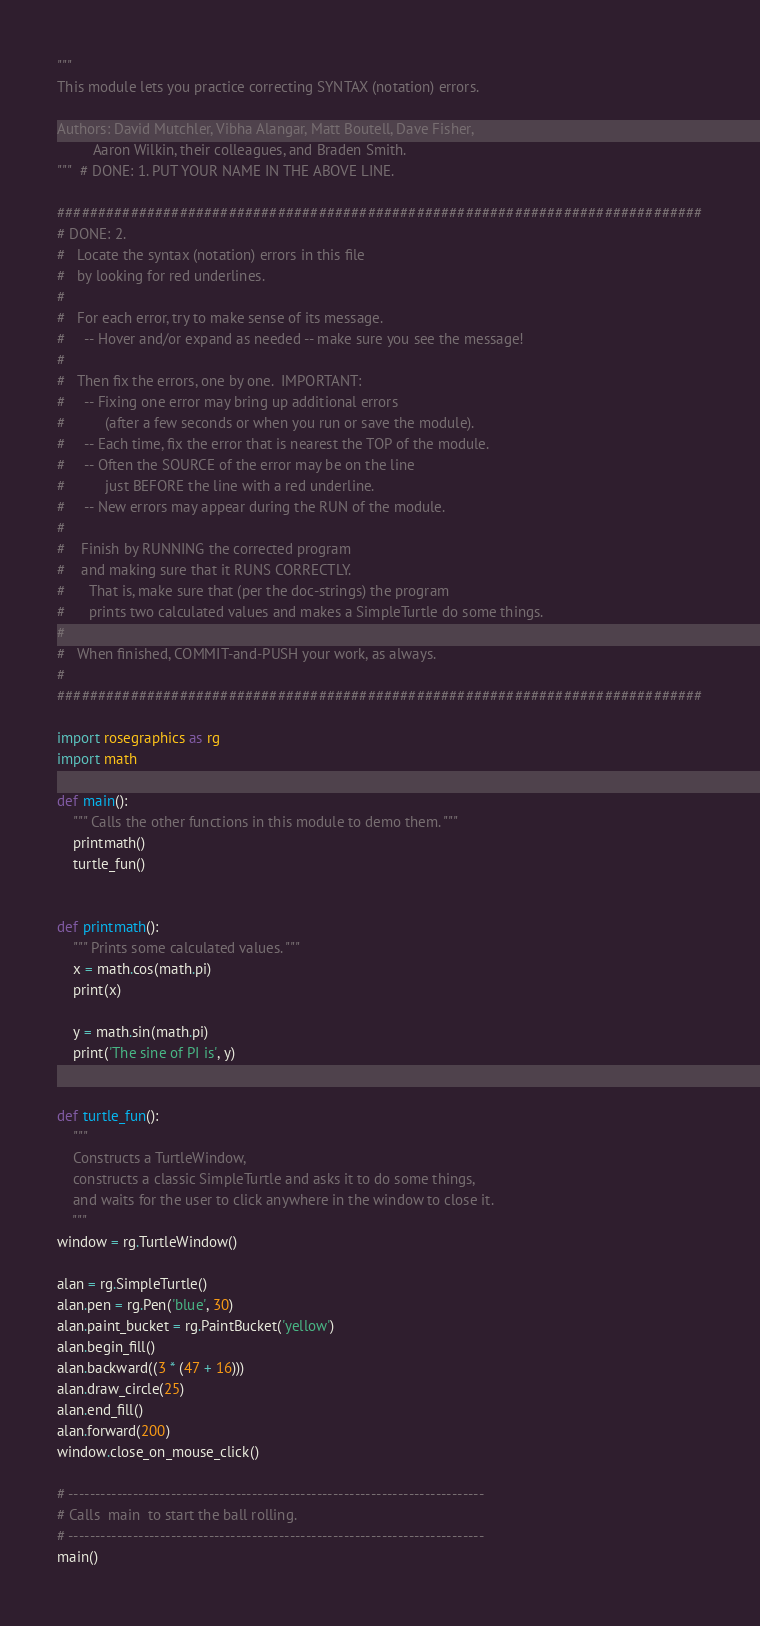Convert code to text. <code><loc_0><loc_0><loc_500><loc_500><_Python_>"""
This module lets you practice correcting SYNTAX (notation) errors.

Authors: David Mutchler, Vibha Alangar, Matt Boutell, Dave Fisher,
         Aaron Wilkin, their colleagues, and Braden Smith.
"""  # DONE: 1. PUT YOUR NAME IN THE ABOVE LINE.

###############################################################################
# DONE: 2.
#   Locate the syntax (notation) errors in this file
#   by looking for red underlines.
#
#   For each error, try to make sense of its message.
#     -- Hover and/or expand as needed -- make sure you see the message!
#
#   Then fix the errors, one by one.  IMPORTANT:
#     -- Fixing one error may bring up additional errors
#          (after a few seconds or when you run or save the module).
#     -- Each time, fix the error that is nearest the TOP of the module.
#     -- Often the SOURCE of the error may be on the line
#          just BEFORE the line with a red underline.
#     -- New errors may appear during the RUN of the module.
#
#    Finish by RUNNING the corrected program
#    and making sure that it RUNS CORRECTLY.
#      That is, make sure that (per the doc-strings) the program
#      prints two calculated values and makes a SimpleTurtle do some things.
#
#   When finished, COMMIT-and-PUSH your work, as always.
#
###############################################################################

import rosegraphics as rg
import math

def main():
    """ Calls the other functions in this module to demo them. """
    printmath()
    turtle_fun()


def printmath():
    """ Prints some calculated values. """
    x = math.cos(math.pi)
    print(x)

    y = math.sin(math.pi)
    print('The sine of PI is', y)


def turtle_fun():
    """
    Constructs a TurtleWindow,
    constructs a classic SimpleTurtle and asks it to do some things,
    and waits for the user to click anywhere in the window to close it.
    """
window = rg.TurtleWindow()

alan = rg.SimpleTurtle()
alan.pen = rg.Pen('blue', 30)
alan.paint_bucket = rg.PaintBucket('yellow')
alan.begin_fill()
alan.backward((3 * (47 + 16)))
alan.draw_circle(25)
alan.end_fill()
alan.forward(200)
window.close_on_mouse_click()

# -----------------------------------------------------------------------------
# Calls  main  to start the ball rolling.
# -----------------------------------------------------------------------------
main()
</code> 